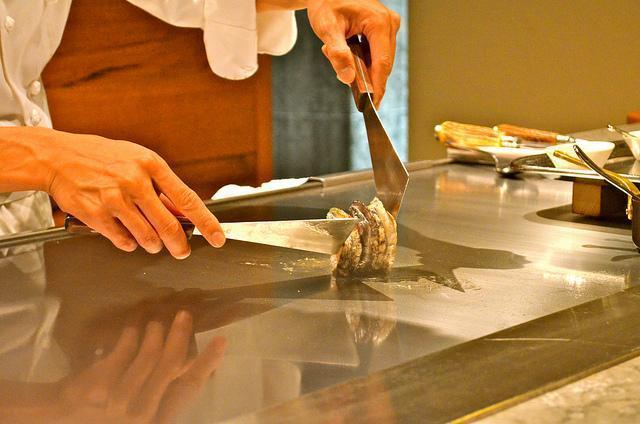How many knives can you see?
Give a very brief answer. 2. How many airplane wheels are to be seen?
Give a very brief answer. 0. 